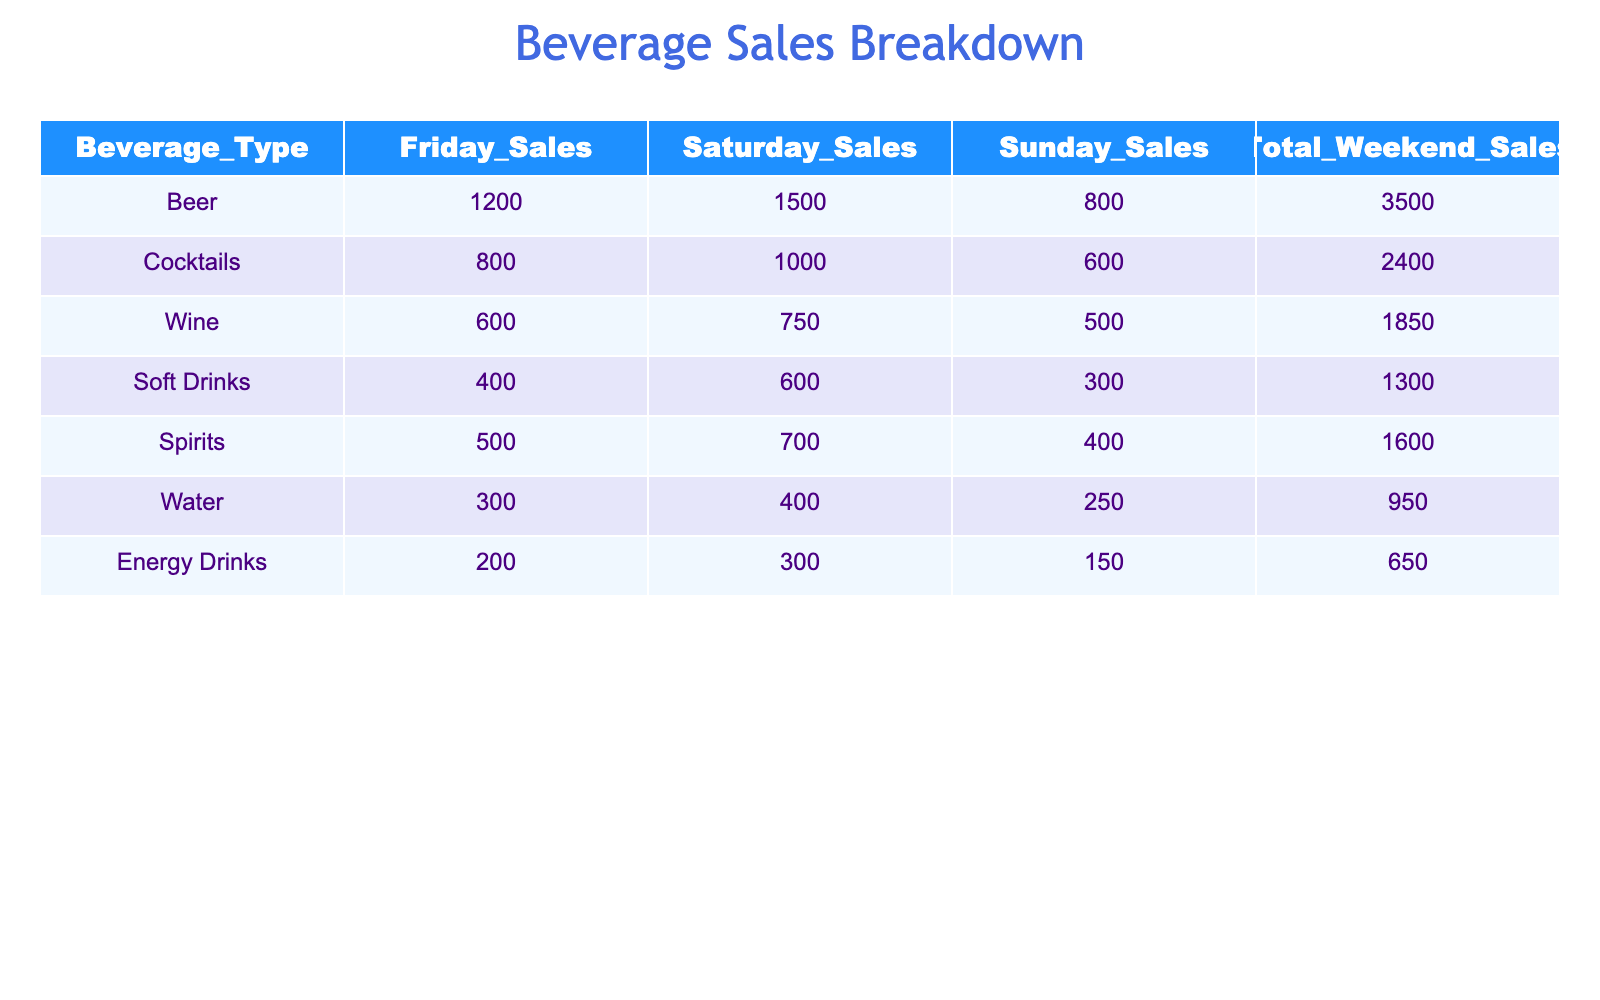What beverage had the highest total weekend sales? By looking at the "Total Weekend Sales" column, we see that Beer has the highest total sales at 3500.
Answer: Beer How many sales do Cocktails generate on Saturday? Referring to the "Saturday Sales" column for Cocktails, it shows 1000.
Answer: 1000 What is the total sales for Soft Drinks on Friday and Sunday combined? The sales for Soft Drinks on Friday are 400 and on Sunday are 300. Adding these together, 400 + 300 equals 700.
Answer: 700 Is the total sales of Wine greater than that of Spirits? The total sales for Wine is 1850 and for Spirits, it is 1600. Since 1850 is greater than 1600, the statement is true.
Answer: Yes What is the average weekend sales of all beverage types? First, we need to sum all total weekend sales: 3500 + 2400 + 1850 + 1300 + 1600 + 950 + 650 = 13650. There are 7 beverage types, so the average is 13650 divided by 7, which is approximately 1950.
Answer: 1950 What was the total sales of Water over the weekend? From the "Total Weekend Sales" column for Water, we can see it generated 950 in total sales.
Answer: 950 Which beverage type generated less than 800 Friday sales? By examining the "Friday Sales" column, we can see that Soft Drinks (400), Water (300), and Energy Drinks (200) all have sales figures less than 800.
Answer: Soft Drinks, Water, Energy Drinks What is the difference in total weekend sales between Beer and Wine? The total weekend sales for Beer is 3500, while for Wine it is 1850. To find the difference, we subtract 1850 from 3500, giving us 1650.
Answer: 1650 How do the sales of Spirits compare to the sales of Energy Drinks over the weekend? The total sales for Spirits is 1600, and for Energy Drinks, it is 650. Comparing these, Spirits has significantly higher sales.
Answer: Spirits has higher sales 